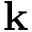<formula> <loc_0><loc_0><loc_500><loc_500>{ k }</formula> 